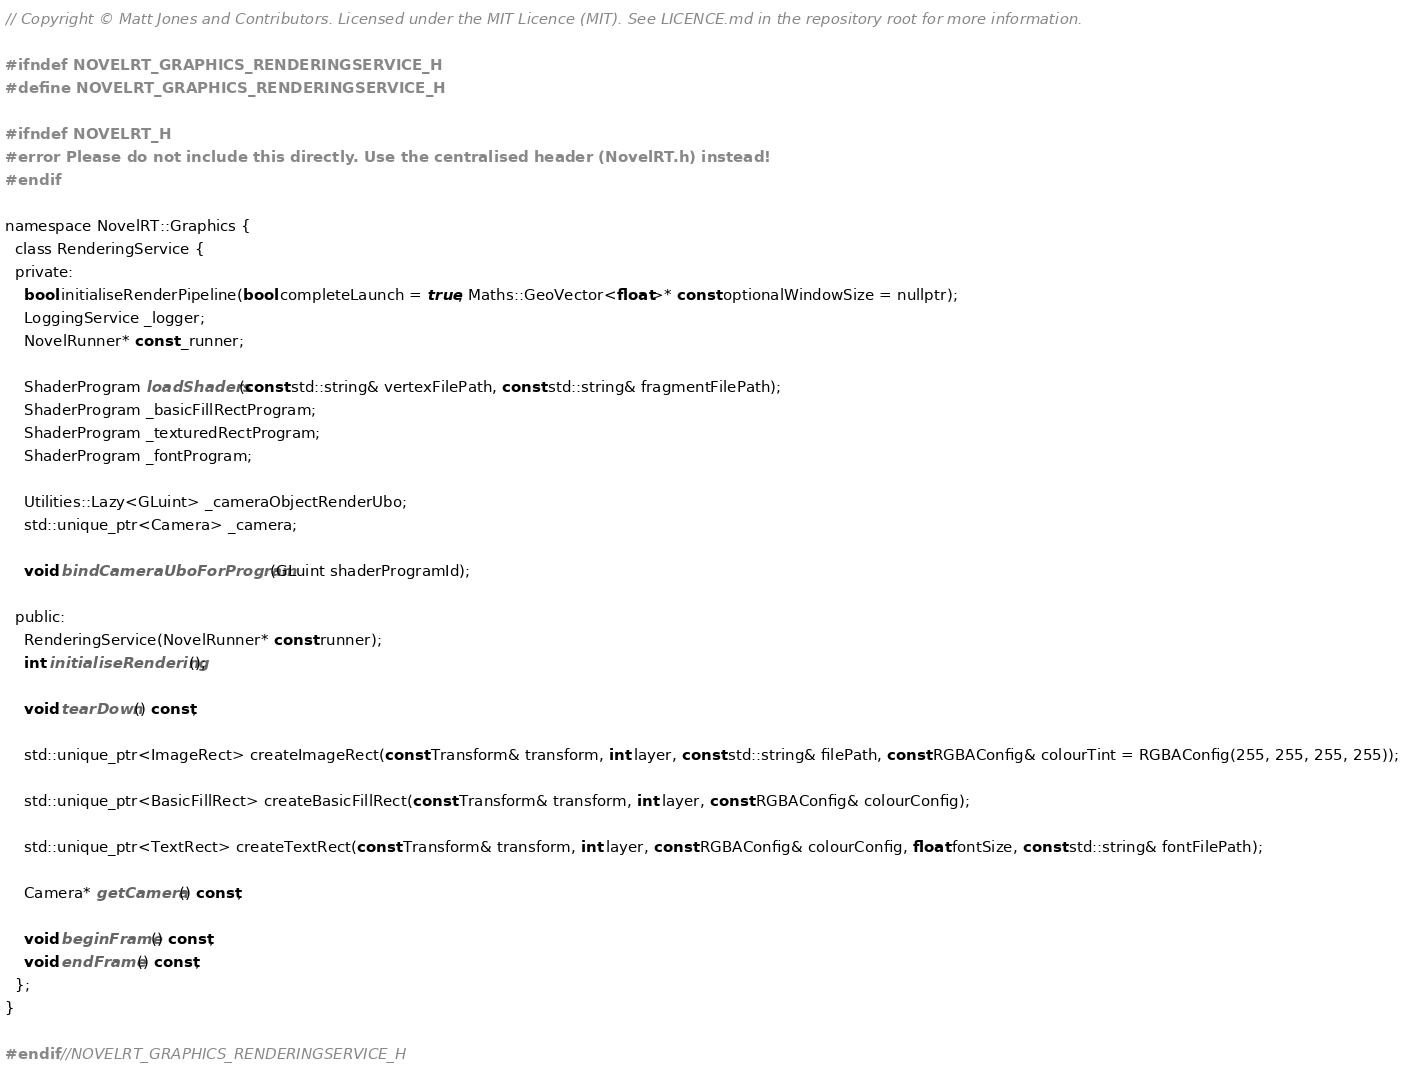<code> <loc_0><loc_0><loc_500><loc_500><_C_>// Copyright © Matt Jones and Contributors. Licensed under the MIT Licence (MIT). See LICENCE.md in the repository root for more information.

#ifndef NOVELRT_GRAPHICS_RENDERINGSERVICE_H
#define NOVELRT_GRAPHICS_RENDERINGSERVICE_H

#ifndef NOVELRT_H
#error Please do not include this directly. Use the centralised header (NovelRT.h) instead!
#endif

namespace NovelRT::Graphics {
  class RenderingService {
  private:
    bool initialiseRenderPipeline(bool completeLaunch = true, Maths::GeoVector<float>* const optionalWindowSize = nullptr);
    LoggingService _logger;
    NovelRunner* const _runner;

    ShaderProgram loadShaders(const std::string& vertexFilePath, const std::string& fragmentFilePath);
    ShaderProgram _basicFillRectProgram;
    ShaderProgram _texturedRectProgram;
    ShaderProgram _fontProgram;

    Utilities::Lazy<GLuint> _cameraObjectRenderUbo;
    std::unique_ptr<Camera> _camera;

    void bindCameraUboForProgram(GLuint shaderProgramId);

  public:
    RenderingService(NovelRunner* const runner);
    int initialiseRendering();

    void tearDown() const;

    std::unique_ptr<ImageRect> createImageRect(const Transform& transform, int layer, const std::string& filePath, const RGBAConfig& colourTint = RGBAConfig(255, 255, 255, 255));

    std::unique_ptr<BasicFillRect> createBasicFillRect(const Transform& transform, int layer, const RGBAConfig& colourConfig);

    std::unique_ptr<TextRect> createTextRect(const Transform& transform, int layer, const RGBAConfig& colourConfig, float fontSize, const std::string& fontFilePath);

    Camera* getCamera() const;

    void beginFrame() const;
    void endFrame() const;
  };
}

#endif //NOVELRT_GRAPHICS_RENDERINGSERVICE_H
</code> 